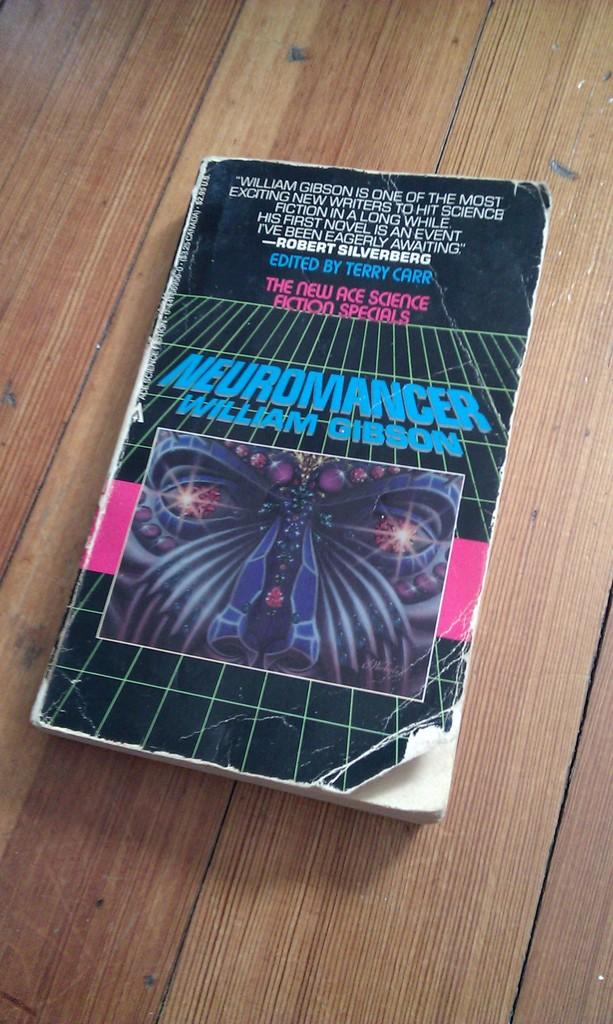Who wrote this book?
Provide a succinct answer. William gibson. What is the name of the book?
Make the answer very short. Neuromancer. 